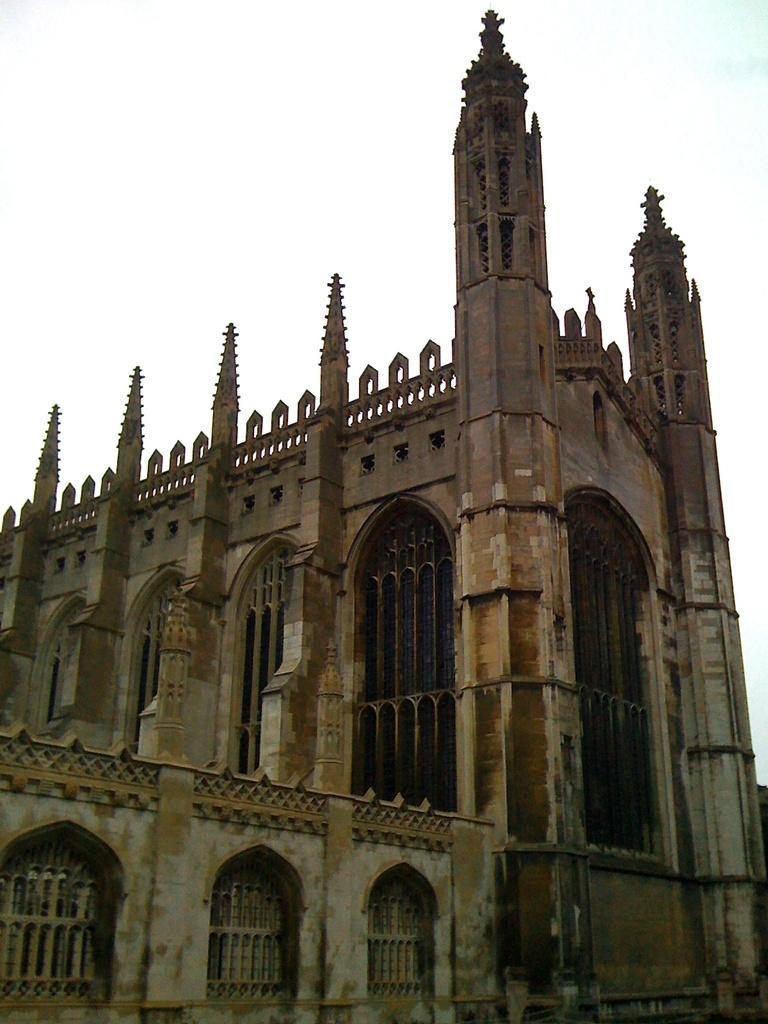Can you describe this image briefly? In this image, this looks like a building with the windows. At the top of the image, I think this is the sky. 